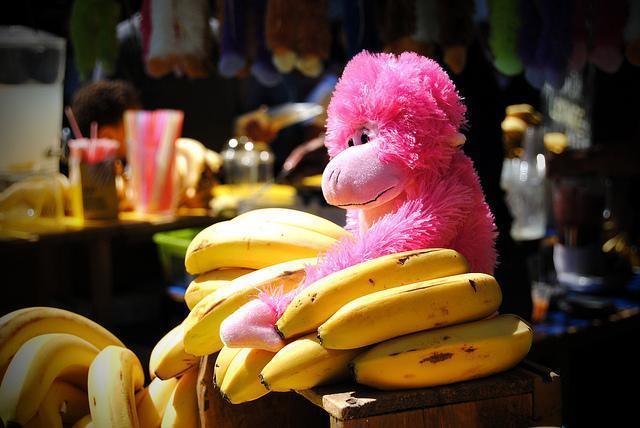How many bananas are there?
Give a very brief answer. 4. 